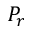Convert formula to latex. <formula><loc_0><loc_0><loc_500><loc_500>P _ { r }</formula> 